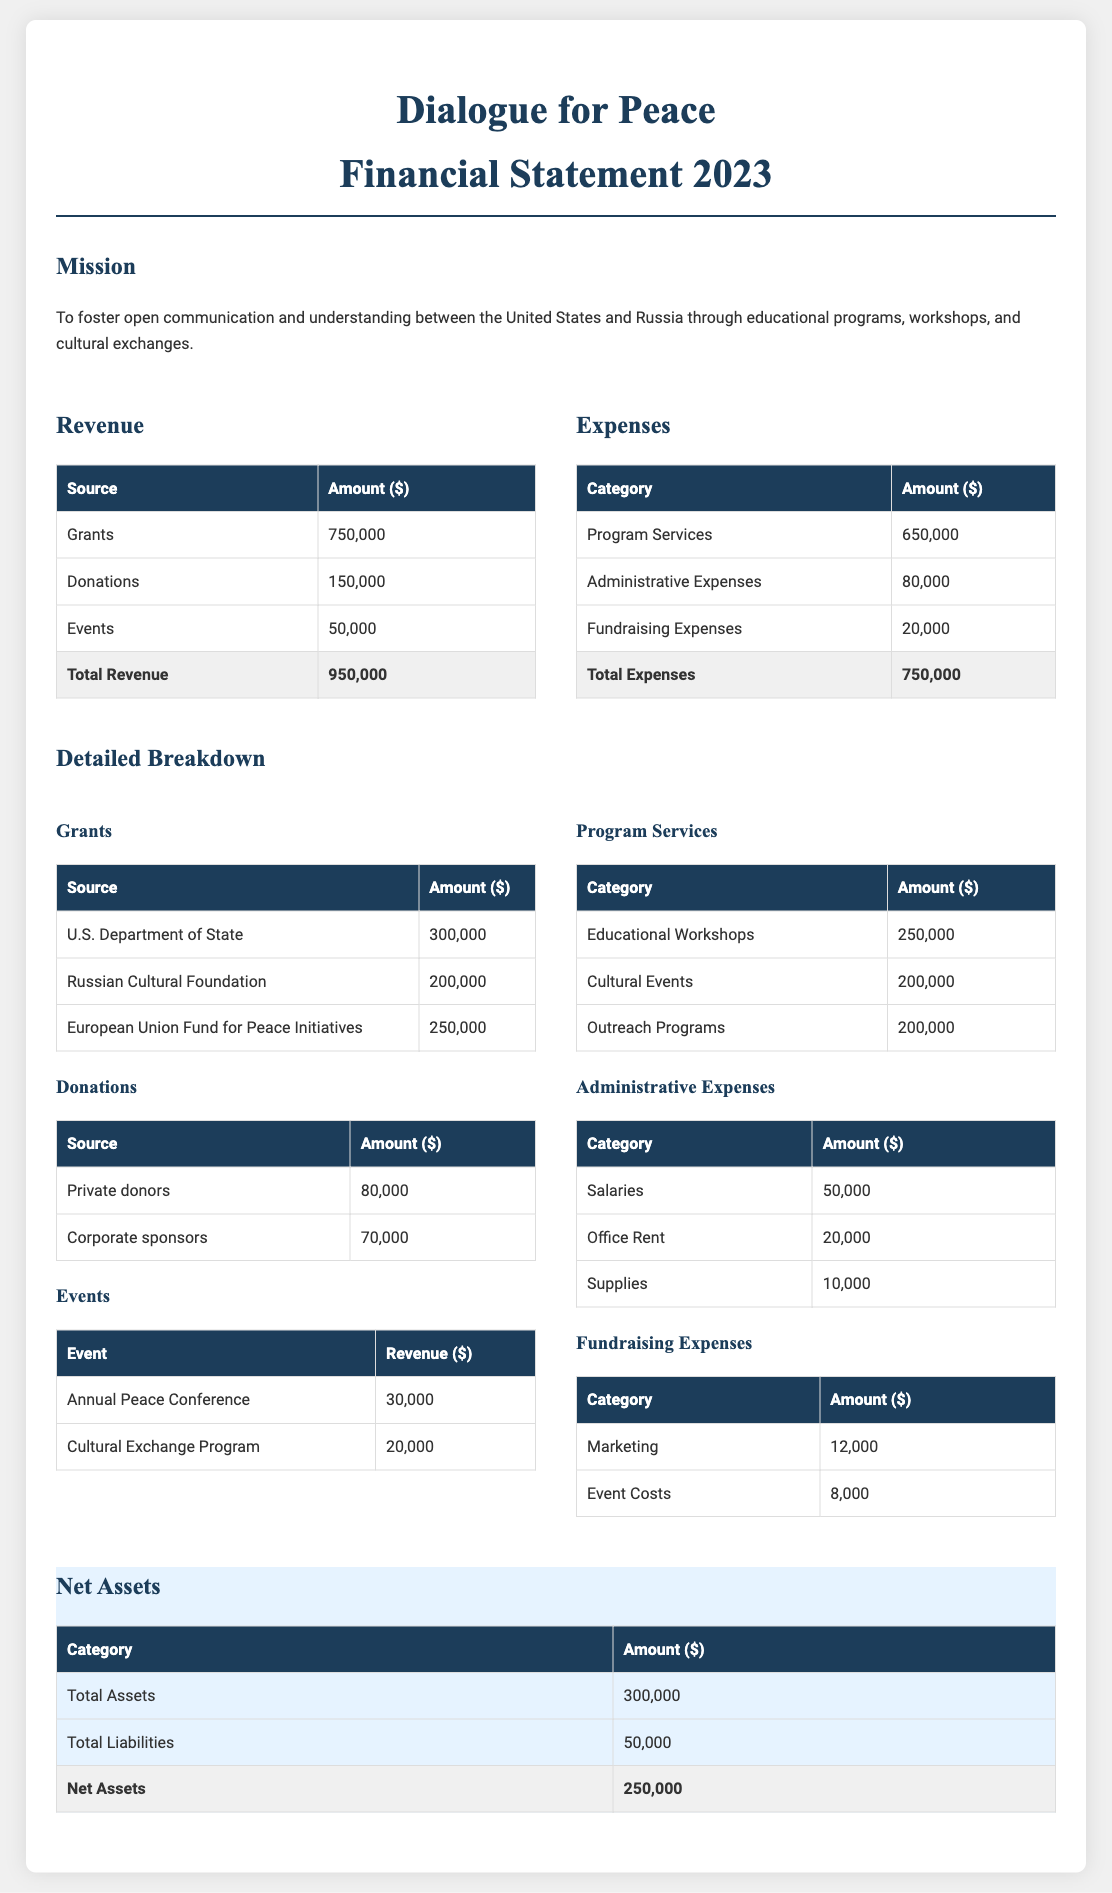What is the total revenue? The total revenue is the sum of all revenue sources provided in the document, specifically $750,000 from grants, $150,000 from donations, and $50,000 from events, totaling $950,000.
Answer: $950,000 What are the program services expenses? The expenses on program services in the document are listed as $650,000, which is a specific category within the total expenses.
Answer: $650,000 Who funded the majority of grants? The U.S. Department of State provided $300,000, which is the highest single grant listed in the breakdown of grants.
Answer: U.S. Department of State What is the total amount spent on administrative expenses? The administrative expenses are detailed individually and sum up to $80,000, which is a specified amount in the expenses section.
Answer: $80,000 What is the net assets value? The net assets value is calculated from total assets of $300,000 minus total liabilities of $50,000, which results in $250,000.
Answer: $250,000 Which event generated the most revenue? The Annual Peace Conference is listed under events, with a revenue of $30,000, making it the highest revenue-generating event.
Answer: Annual Peace Conference What percentage of the total revenue is from donations? Donations amount to $150,000, which is 15.79% of the total revenue ($950,000), calculated based on the figures in the statement.
Answer: 15.79% What is the total amount received from the European Union Fund for Peace Initiatives? The amount received from the European Union Fund for Peace Initiatives is listed as $250,000 in the grants section of the document.
Answer: $250,000 What are the total liabilities? The document states total liabilities are $50,000, which is explicitly mentioned in the net assets section.
Answer: $50,000 